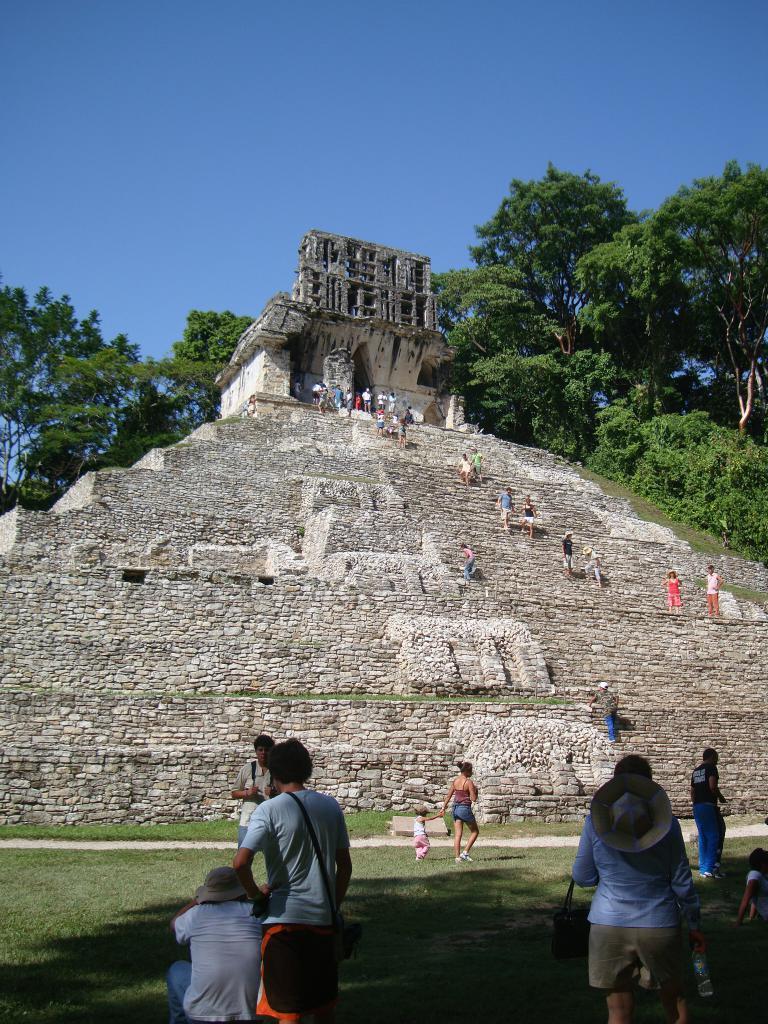Please provide a concise description of this image. This picture is clicked outside. In the foreground we can see the group of persons. In the center there is a fort and we can see the group of persons climbing the stairs of a fort. In the background there is a sky, trees and some plants. 